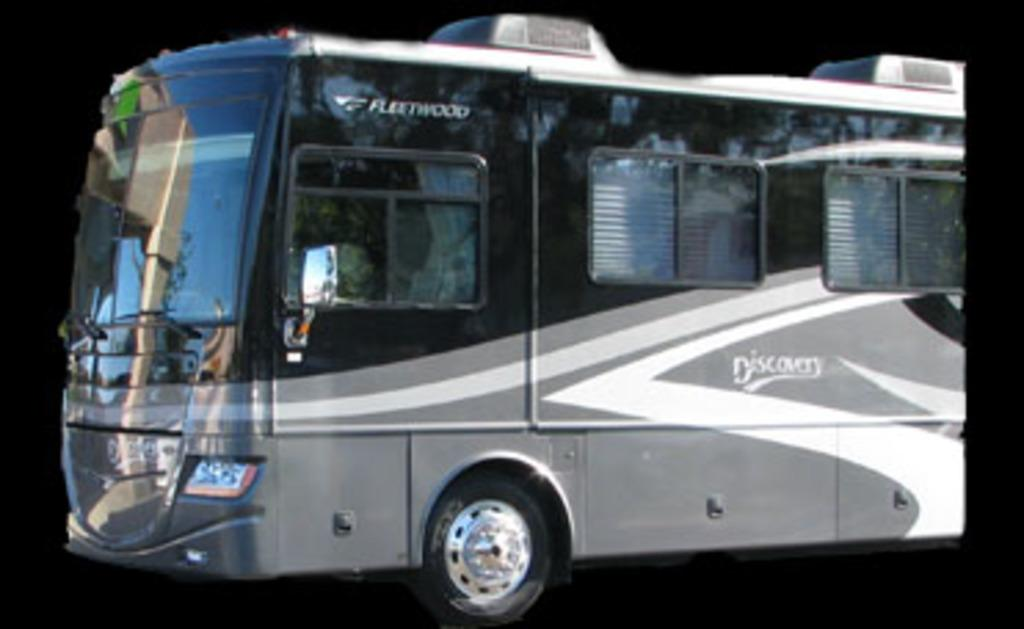What is the main subject of the picture? The main subject of the picture is an image of a bus. Where is the bus located in the image? The bus is towards the left side of the image. What color is the background of the image? The background of the image is black. Can you tell me how many grapes are on the bus in the image? There are no grapes present in the image; it features an image of a bus with a black background. Are there any fairies visible near the bus in the image? There are no fairies present in the image; it features an image of a bus with a black background. 